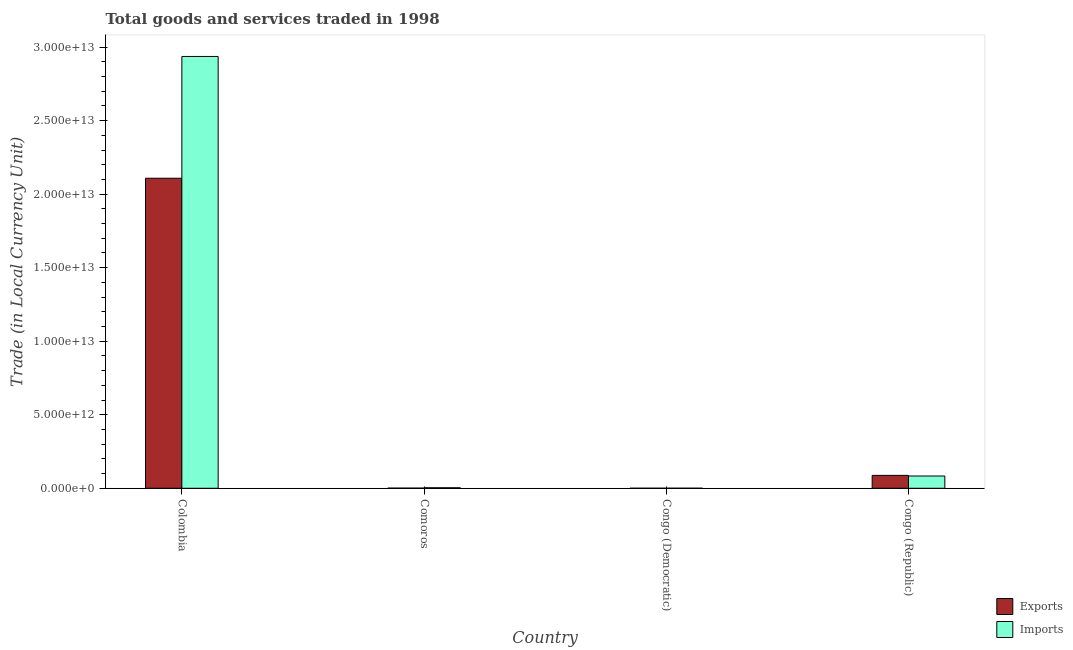How many different coloured bars are there?
Provide a short and direct response. 2. How many groups of bars are there?
Keep it short and to the point. 4. Are the number of bars per tick equal to the number of legend labels?
Your answer should be compact. Yes. What is the label of the 2nd group of bars from the left?
Make the answer very short. Comoros. What is the export of goods and services in Congo (Democratic)?
Keep it short and to the point. 2.98e+09. Across all countries, what is the maximum imports of goods and services?
Make the answer very short. 2.94e+13. Across all countries, what is the minimum imports of goods and services?
Your answer should be very brief. 3.29e+09. In which country was the imports of goods and services maximum?
Provide a short and direct response. Colombia. In which country was the imports of goods and services minimum?
Offer a very short reply. Congo (Democratic). What is the total imports of goods and services in the graph?
Offer a very short reply. 3.02e+13. What is the difference between the export of goods and services in Comoros and that in Congo (Democratic)?
Provide a short and direct response. 7.84e+09. What is the difference between the imports of goods and services in Congo (Republic) and the export of goods and services in Comoros?
Give a very brief answer. 8.24e+11. What is the average export of goods and services per country?
Offer a very short reply. 5.49e+12. What is the difference between the export of goods and services and imports of goods and services in Congo (Democratic)?
Your response must be concise. -3.10e+08. What is the ratio of the export of goods and services in Congo (Democratic) to that in Congo (Republic)?
Your response must be concise. 0. Is the imports of goods and services in Comoros less than that in Congo (Republic)?
Your response must be concise. Yes. Is the difference between the export of goods and services in Comoros and Congo (Republic) greater than the difference between the imports of goods and services in Comoros and Congo (Republic)?
Your answer should be very brief. No. What is the difference between the highest and the second highest export of goods and services?
Offer a terse response. 2.02e+13. What is the difference between the highest and the lowest imports of goods and services?
Give a very brief answer. 2.94e+13. In how many countries, is the export of goods and services greater than the average export of goods and services taken over all countries?
Give a very brief answer. 1. Is the sum of the imports of goods and services in Colombia and Congo (Republic) greater than the maximum export of goods and services across all countries?
Your answer should be very brief. Yes. What does the 1st bar from the left in Congo (Republic) represents?
Your answer should be compact. Exports. What does the 1st bar from the right in Comoros represents?
Offer a terse response. Imports. Are all the bars in the graph horizontal?
Ensure brevity in your answer.  No. How many countries are there in the graph?
Your answer should be very brief. 4. What is the difference between two consecutive major ticks on the Y-axis?
Your response must be concise. 5.00e+12. Are the values on the major ticks of Y-axis written in scientific E-notation?
Keep it short and to the point. Yes. Does the graph contain any zero values?
Give a very brief answer. No. Does the graph contain grids?
Ensure brevity in your answer.  No. How many legend labels are there?
Your answer should be compact. 2. How are the legend labels stacked?
Your answer should be compact. Vertical. What is the title of the graph?
Make the answer very short. Total goods and services traded in 1998. Does "Under five" appear as one of the legend labels in the graph?
Give a very brief answer. No. What is the label or title of the X-axis?
Your answer should be compact. Country. What is the label or title of the Y-axis?
Make the answer very short. Trade (in Local Currency Unit). What is the Trade (in Local Currency Unit) in Exports in Colombia?
Provide a short and direct response. 2.11e+13. What is the Trade (in Local Currency Unit) of Imports in Colombia?
Your answer should be compact. 2.94e+13. What is the Trade (in Local Currency Unit) in Exports in Comoros?
Keep it short and to the point. 1.08e+1. What is the Trade (in Local Currency Unit) of Imports in Comoros?
Your response must be concise. 3.55e+1. What is the Trade (in Local Currency Unit) of Exports in Congo (Democratic)?
Give a very brief answer. 2.98e+09. What is the Trade (in Local Currency Unit) in Imports in Congo (Democratic)?
Offer a terse response. 3.29e+09. What is the Trade (in Local Currency Unit) of Exports in Congo (Republic)?
Your answer should be very brief. 8.77e+11. What is the Trade (in Local Currency Unit) in Imports in Congo (Republic)?
Offer a very short reply. 8.35e+11. Across all countries, what is the maximum Trade (in Local Currency Unit) in Exports?
Your answer should be compact. 2.11e+13. Across all countries, what is the maximum Trade (in Local Currency Unit) in Imports?
Provide a succinct answer. 2.94e+13. Across all countries, what is the minimum Trade (in Local Currency Unit) of Exports?
Keep it short and to the point. 2.98e+09. Across all countries, what is the minimum Trade (in Local Currency Unit) in Imports?
Give a very brief answer. 3.29e+09. What is the total Trade (in Local Currency Unit) of Exports in the graph?
Provide a succinct answer. 2.20e+13. What is the total Trade (in Local Currency Unit) of Imports in the graph?
Ensure brevity in your answer.  3.02e+13. What is the difference between the Trade (in Local Currency Unit) of Exports in Colombia and that in Comoros?
Your response must be concise. 2.11e+13. What is the difference between the Trade (in Local Currency Unit) of Imports in Colombia and that in Comoros?
Ensure brevity in your answer.  2.93e+13. What is the difference between the Trade (in Local Currency Unit) in Exports in Colombia and that in Congo (Democratic)?
Your answer should be very brief. 2.11e+13. What is the difference between the Trade (in Local Currency Unit) of Imports in Colombia and that in Congo (Democratic)?
Keep it short and to the point. 2.94e+13. What is the difference between the Trade (in Local Currency Unit) of Exports in Colombia and that in Congo (Republic)?
Give a very brief answer. 2.02e+13. What is the difference between the Trade (in Local Currency Unit) of Imports in Colombia and that in Congo (Republic)?
Provide a succinct answer. 2.85e+13. What is the difference between the Trade (in Local Currency Unit) in Exports in Comoros and that in Congo (Democratic)?
Offer a terse response. 7.84e+09. What is the difference between the Trade (in Local Currency Unit) of Imports in Comoros and that in Congo (Democratic)?
Your answer should be compact. 3.22e+1. What is the difference between the Trade (in Local Currency Unit) in Exports in Comoros and that in Congo (Republic)?
Offer a very short reply. -8.66e+11. What is the difference between the Trade (in Local Currency Unit) in Imports in Comoros and that in Congo (Republic)?
Your response must be concise. -8.00e+11. What is the difference between the Trade (in Local Currency Unit) in Exports in Congo (Democratic) and that in Congo (Republic)?
Provide a short and direct response. -8.74e+11. What is the difference between the Trade (in Local Currency Unit) in Imports in Congo (Democratic) and that in Congo (Republic)?
Offer a very short reply. -8.32e+11. What is the difference between the Trade (in Local Currency Unit) in Exports in Colombia and the Trade (in Local Currency Unit) in Imports in Comoros?
Your answer should be very brief. 2.10e+13. What is the difference between the Trade (in Local Currency Unit) of Exports in Colombia and the Trade (in Local Currency Unit) of Imports in Congo (Democratic)?
Provide a succinct answer. 2.11e+13. What is the difference between the Trade (in Local Currency Unit) of Exports in Colombia and the Trade (in Local Currency Unit) of Imports in Congo (Republic)?
Your response must be concise. 2.02e+13. What is the difference between the Trade (in Local Currency Unit) in Exports in Comoros and the Trade (in Local Currency Unit) in Imports in Congo (Democratic)?
Keep it short and to the point. 7.54e+09. What is the difference between the Trade (in Local Currency Unit) of Exports in Comoros and the Trade (in Local Currency Unit) of Imports in Congo (Republic)?
Ensure brevity in your answer.  -8.24e+11. What is the difference between the Trade (in Local Currency Unit) in Exports in Congo (Democratic) and the Trade (in Local Currency Unit) in Imports in Congo (Republic)?
Keep it short and to the point. -8.32e+11. What is the average Trade (in Local Currency Unit) of Exports per country?
Provide a short and direct response. 5.49e+12. What is the average Trade (in Local Currency Unit) of Imports per country?
Keep it short and to the point. 7.56e+12. What is the difference between the Trade (in Local Currency Unit) in Exports and Trade (in Local Currency Unit) in Imports in Colombia?
Your response must be concise. -8.28e+12. What is the difference between the Trade (in Local Currency Unit) in Exports and Trade (in Local Currency Unit) in Imports in Comoros?
Offer a terse response. -2.47e+1. What is the difference between the Trade (in Local Currency Unit) in Exports and Trade (in Local Currency Unit) in Imports in Congo (Democratic)?
Your answer should be very brief. -3.10e+08. What is the difference between the Trade (in Local Currency Unit) in Exports and Trade (in Local Currency Unit) in Imports in Congo (Republic)?
Ensure brevity in your answer.  4.20e+1. What is the ratio of the Trade (in Local Currency Unit) in Exports in Colombia to that in Comoros?
Your answer should be very brief. 1948.33. What is the ratio of the Trade (in Local Currency Unit) in Imports in Colombia to that in Comoros?
Ensure brevity in your answer.  826.97. What is the ratio of the Trade (in Local Currency Unit) in Exports in Colombia to that in Congo (Democratic)?
Provide a short and direct response. 7084.28. What is the ratio of the Trade (in Local Currency Unit) in Imports in Colombia to that in Congo (Democratic)?
Offer a terse response. 8936.94. What is the ratio of the Trade (in Local Currency Unit) of Exports in Colombia to that in Congo (Republic)?
Give a very brief answer. 24.03. What is the ratio of the Trade (in Local Currency Unit) of Imports in Colombia to that in Congo (Republic)?
Provide a short and direct response. 35.16. What is the ratio of the Trade (in Local Currency Unit) of Exports in Comoros to that in Congo (Democratic)?
Your answer should be compact. 3.64. What is the ratio of the Trade (in Local Currency Unit) of Imports in Comoros to that in Congo (Democratic)?
Offer a very short reply. 10.81. What is the ratio of the Trade (in Local Currency Unit) in Exports in Comoros to that in Congo (Republic)?
Keep it short and to the point. 0.01. What is the ratio of the Trade (in Local Currency Unit) of Imports in Comoros to that in Congo (Republic)?
Offer a terse response. 0.04. What is the ratio of the Trade (in Local Currency Unit) in Exports in Congo (Democratic) to that in Congo (Republic)?
Give a very brief answer. 0. What is the ratio of the Trade (in Local Currency Unit) of Imports in Congo (Democratic) to that in Congo (Republic)?
Make the answer very short. 0. What is the difference between the highest and the second highest Trade (in Local Currency Unit) of Exports?
Offer a terse response. 2.02e+13. What is the difference between the highest and the second highest Trade (in Local Currency Unit) of Imports?
Offer a terse response. 2.85e+13. What is the difference between the highest and the lowest Trade (in Local Currency Unit) in Exports?
Make the answer very short. 2.11e+13. What is the difference between the highest and the lowest Trade (in Local Currency Unit) in Imports?
Your response must be concise. 2.94e+13. 